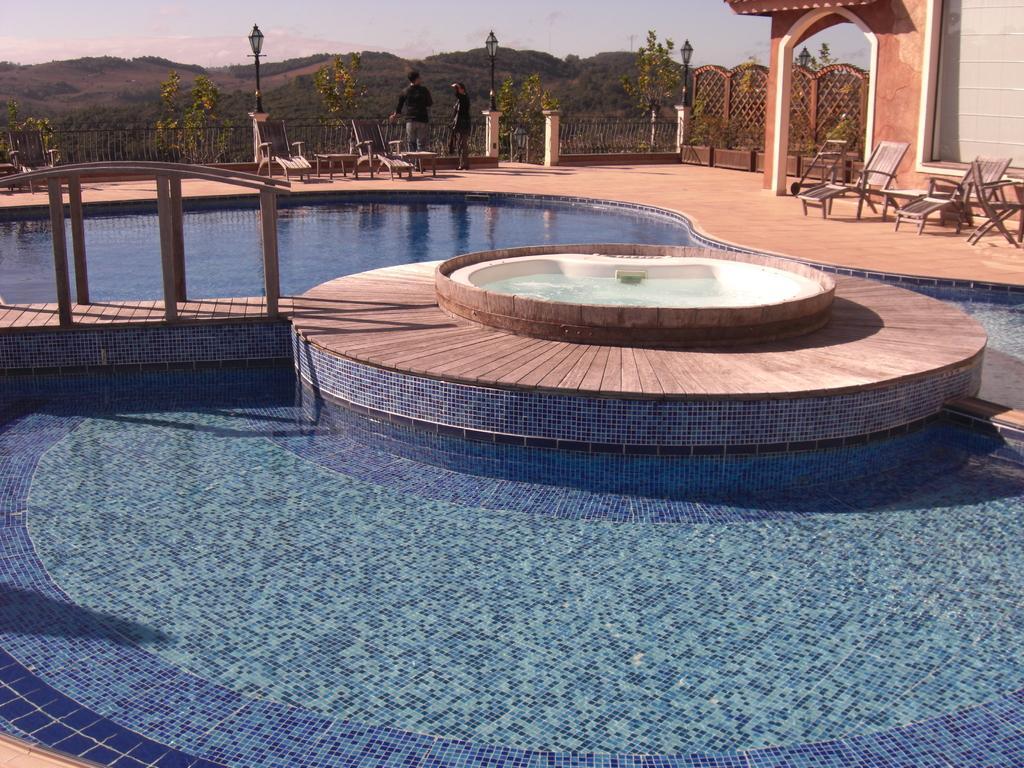How would you summarize this image in a sentence or two? In the foreground of this image, there is a swimming pool. Behind it, there are wooden chairs, people standing, railing, lamps and an arch. In the background, there are trees, slope ground and the sky. 